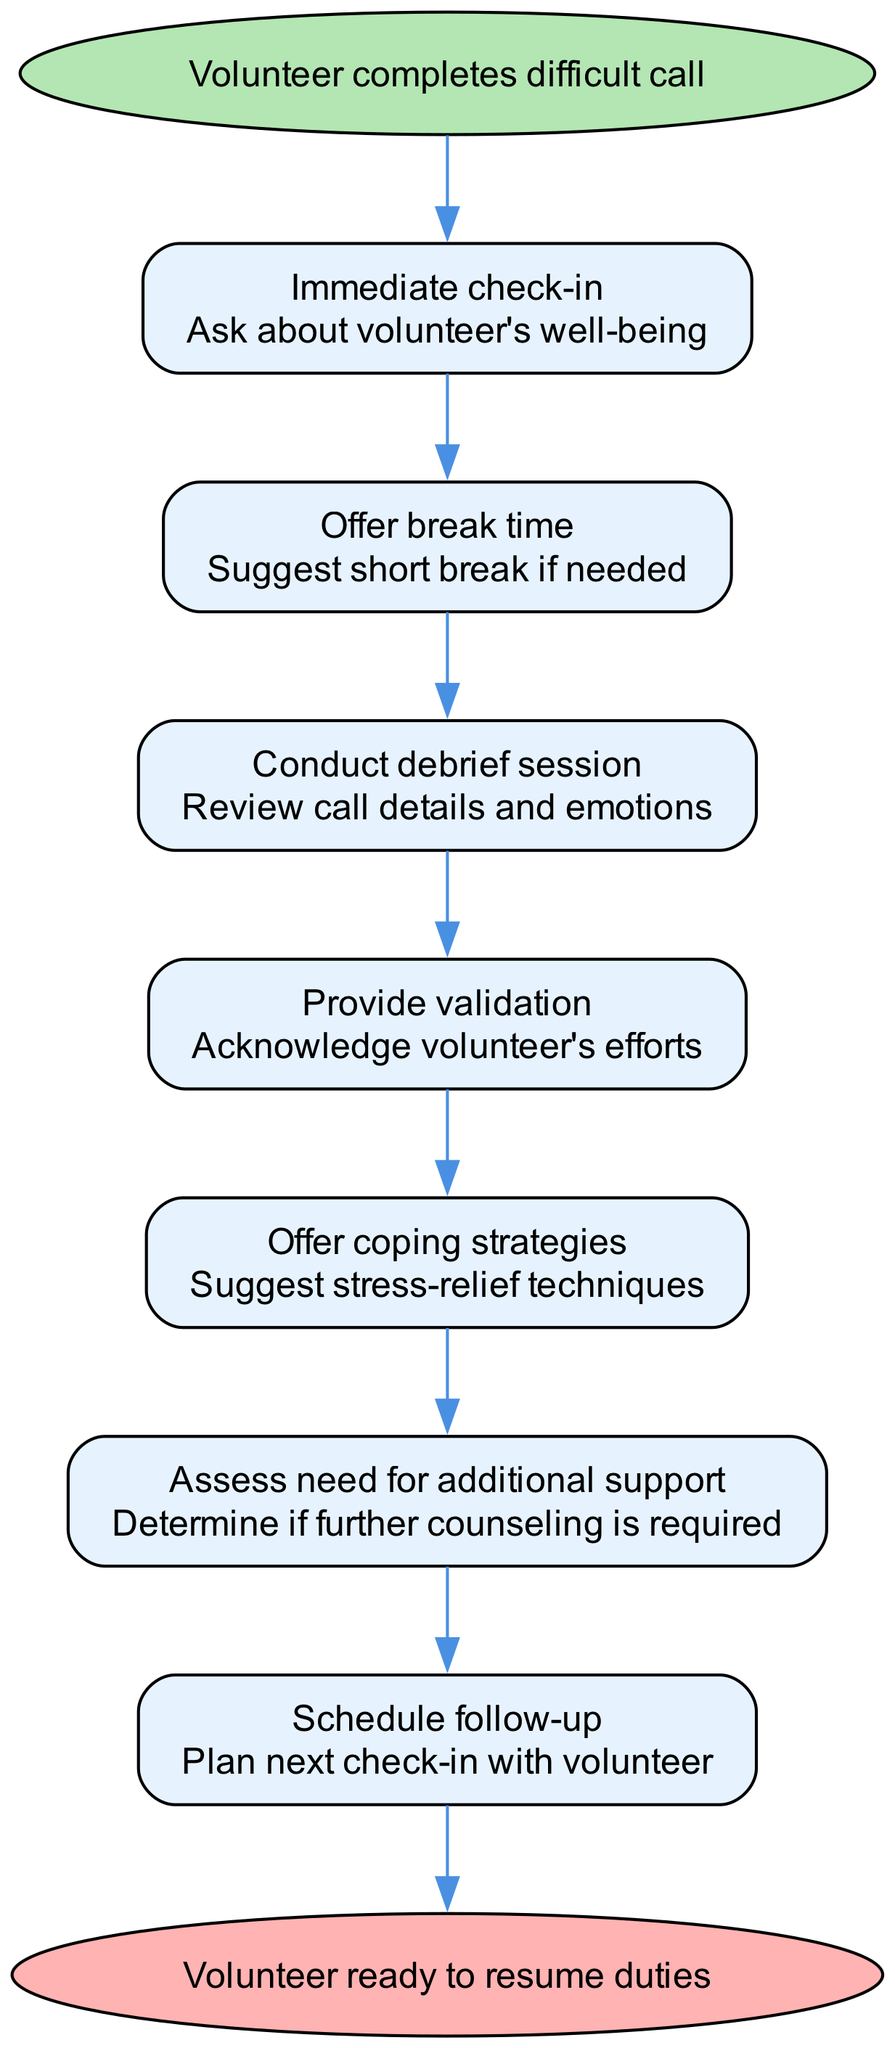What is the first action in the flowchart? The first action in the flowchart is labeled as "Immediate check-in," which is the first step taken after the volunteer completes a difficult call.
Answer: Immediate check-in How many steps are there in total? Counting the steps listed after the starting point, there are six total actions outlined in the flowchart.
Answer: 6 What action occurs just before "Assess need for additional support"? Reviewing the flowchart, the action that occurs just before "Assess need for additional support" is "Offer coping strategies."
Answer: Offer coping strategies What is the final outcome of the process? The final outcome, reflected in the end node of the flowchart, is that the "Volunteer ready to resume duties." The diagram's end node clearly indicates the conclusion of the outlined procedures.
Answer: Volunteer ready to resume duties Which step includes acknowledging the volunteer's efforts? The step that specifically includes acknowledging the volunteer's efforts is labeled as "Provide validation."
Answer: Provide validation What is the second action in the flowchart? The second action is "Offer break time," indicating a suggestion made after the immediate check-in to allow the volunteer to take a break if needed.
Answer: Offer break time What happens after the "Conduct debrief session"? Following "Conduct debrief session," the next action taken is "Provide validation," which focuses on acknowledging the volunteer's experience and efforts.
Answer: Provide validation How does "Schedule follow-up" relate to the other actions? The "Schedule follow-up" action occurs as the final step that ensures ongoing support and check-in with the volunteer after the previous steps have been completed. It effectively ties back to the earlier actions by emphasizing continued care.
Answer: Ongoing support 